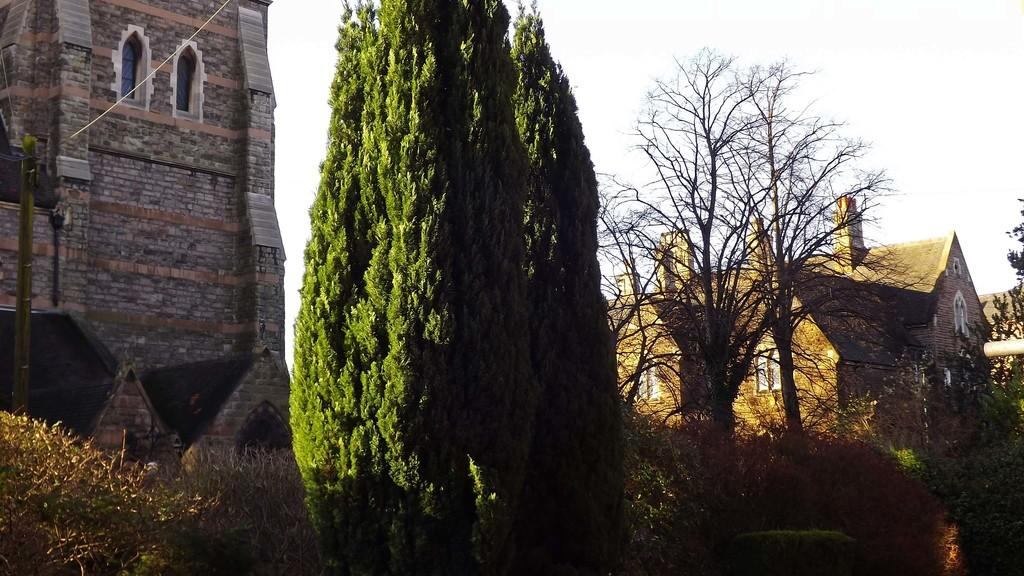What type of structures are visible in the image? There are buildings with windows in the image. What type of vegetation can be seen in the image? There are trees in the image. What type of plants are located at the bottom of the image? There are bushes at the bottom of the image. What is visible in the background of the image? The sky is visible in the image. What type of tax is being discussed in the image? There is no discussion of tax in the image; it features buildings, trees, bushes, and the sky. What team is playing in the image? There is no team or game present in the image. 